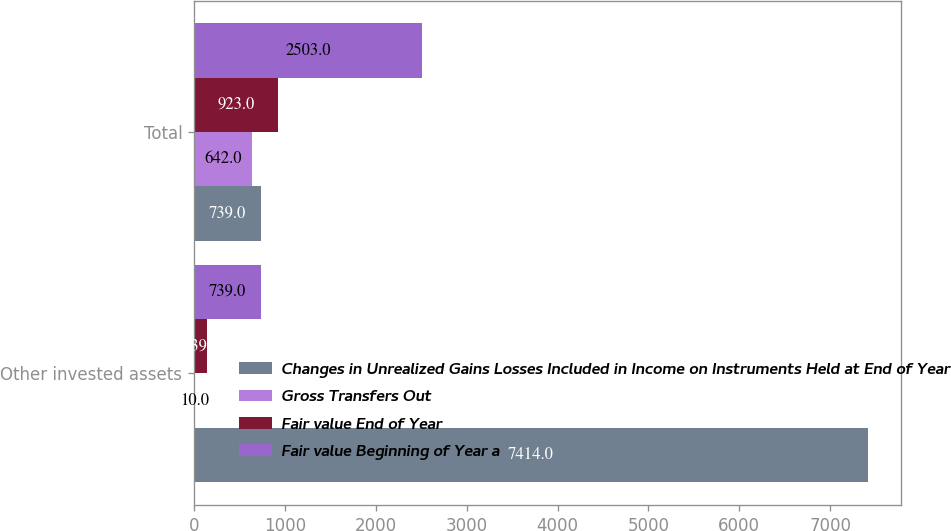Convert chart. <chart><loc_0><loc_0><loc_500><loc_500><stacked_bar_chart><ecel><fcel>Other invested assets<fcel>Total<nl><fcel>Changes in Unrealized Gains Losses Included in Income on Instruments Held at End of Year<fcel>7414<fcel>739<nl><fcel>Gross Transfers Out<fcel>10<fcel>642<nl><fcel>Fair value End of Year<fcel>139<fcel>923<nl><fcel>Fair value Beginning of Year a<fcel>739<fcel>2503<nl></chart> 